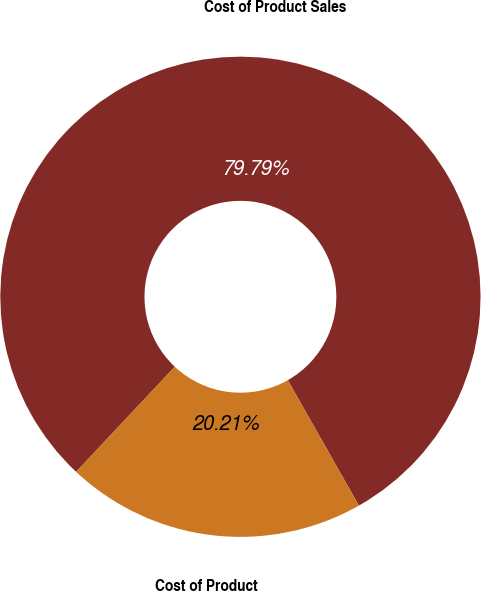Convert chart to OTSL. <chart><loc_0><loc_0><loc_500><loc_500><pie_chart><fcel>Cost of Product Sales<fcel>Cost of Product<nl><fcel>79.79%<fcel>20.21%<nl></chart> 